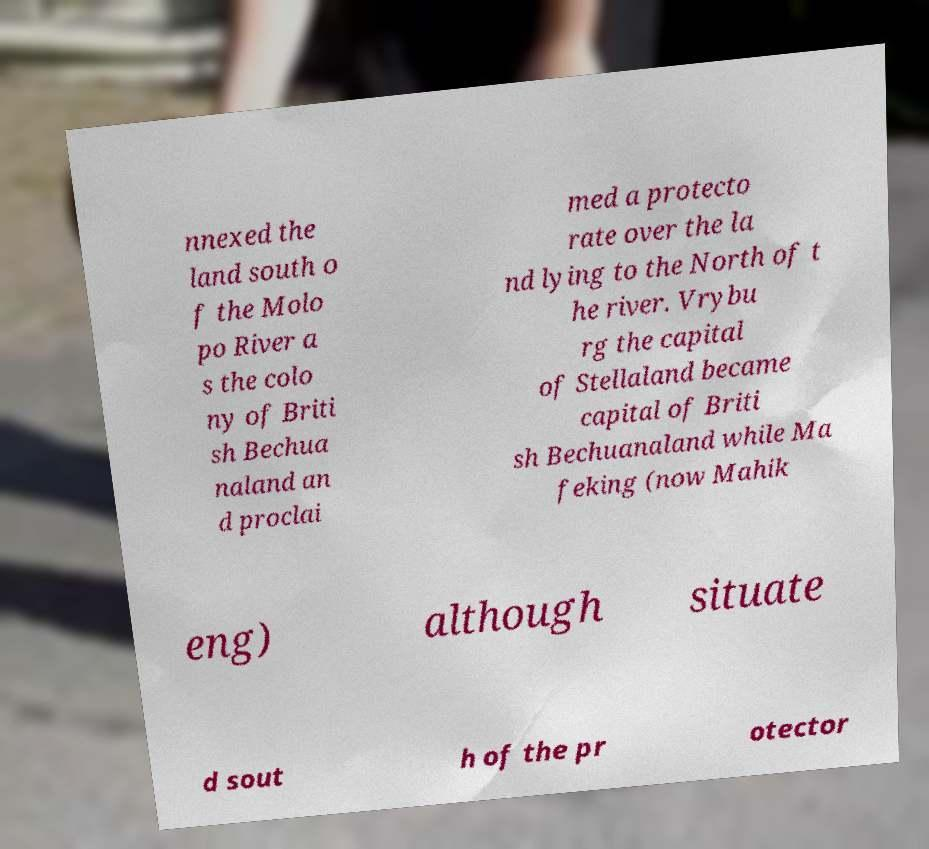What messages or text are displayed in this image? I need them in a readable, typed format. nnexed the land south o f the Molo po River a s the colo ny of Briti sh Bechua naland an d proclai med a protecto rate over the la nd lying to the North of t he river. Vrybu rg the capital of Stellaland became capital of Briti sh Bechuanaland while Ma feking (now Mahik eng) although situate d sout h of the pr otector 